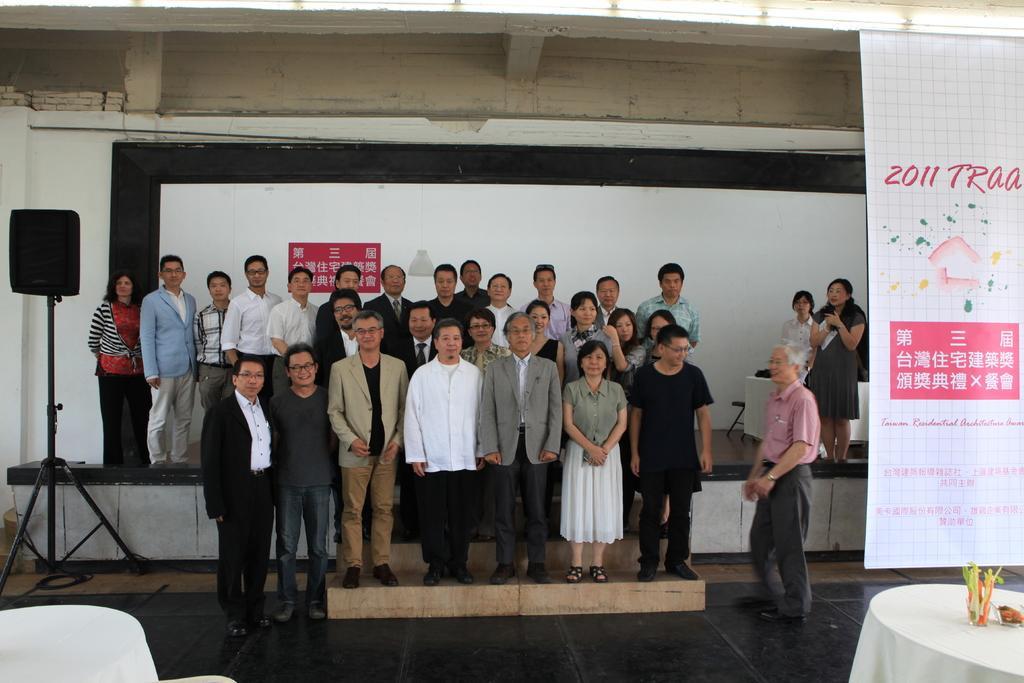Please provide a concise description of this image. There are group of people standing. I think this is a screen. This looks like a lamp hanging. I can see a speaker with a stand. Here is a banner, which is hanging. On the right side of the image, I can see a table, which is just covered with a white cloth. This looks like a small flower vase on the table. Here is another table on the stage. 